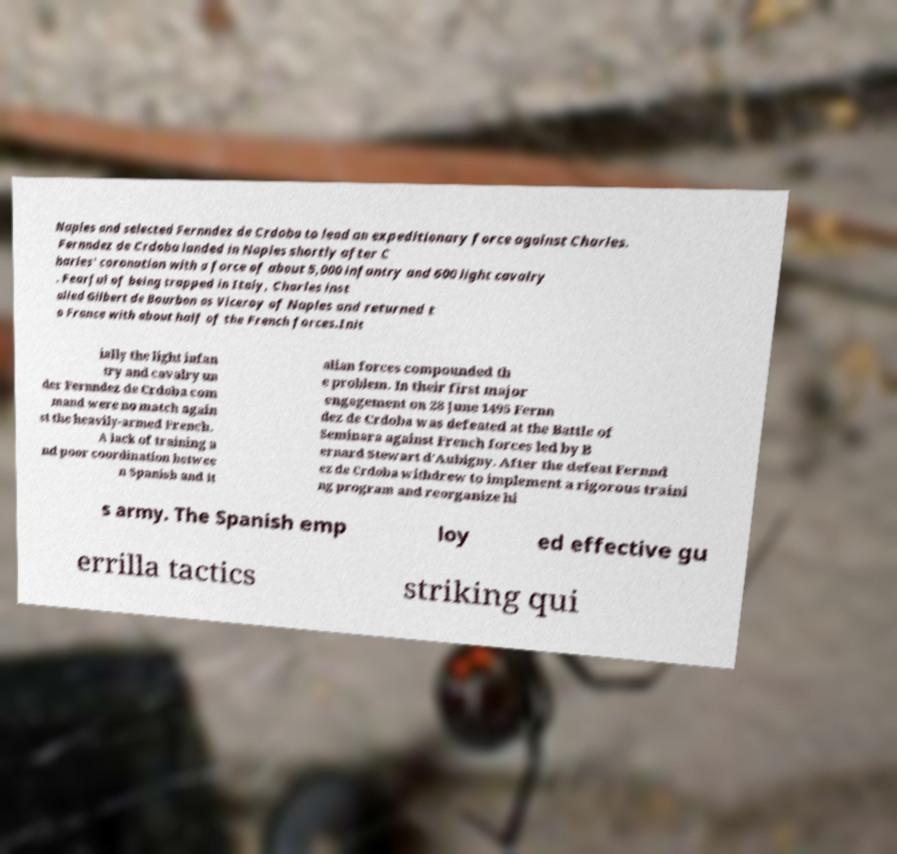Could you assist in decoding the text presented in this image and type it out clearly? Naples and selected Fernndez de Crdoba to lead an expeditionary force against Charles. Fernndez de Crdoba landed in Naples shortly after C harles' coronation with a force of about 5,000 infantry and 600 light cavalry . Fearful of being trapped in Italy, Charles inst alled Gilbert de Bourbon as Viceroy of Naples and returned t o France with about half of the French forces.Init ially the light infan try and cavalry un der Fernndez de Crdoba com mand were no match again st the heavily-armed French. A lack of training a nd poor coordination betwee n Spanish and It alian forces compounded th e problem. In their first major engagement on 28 June 1495 Fernn dez de Crdoba was defeated at the Battle of Seminara against French forces led by B ernard Stewart d'Aubigny. After the defeat Fernnd ez de Crdoba withdrew to implement a rigorous traini ng program and reorganize hi s army. The Spanish emp loy ed effective gu errilla tactics striking qui 